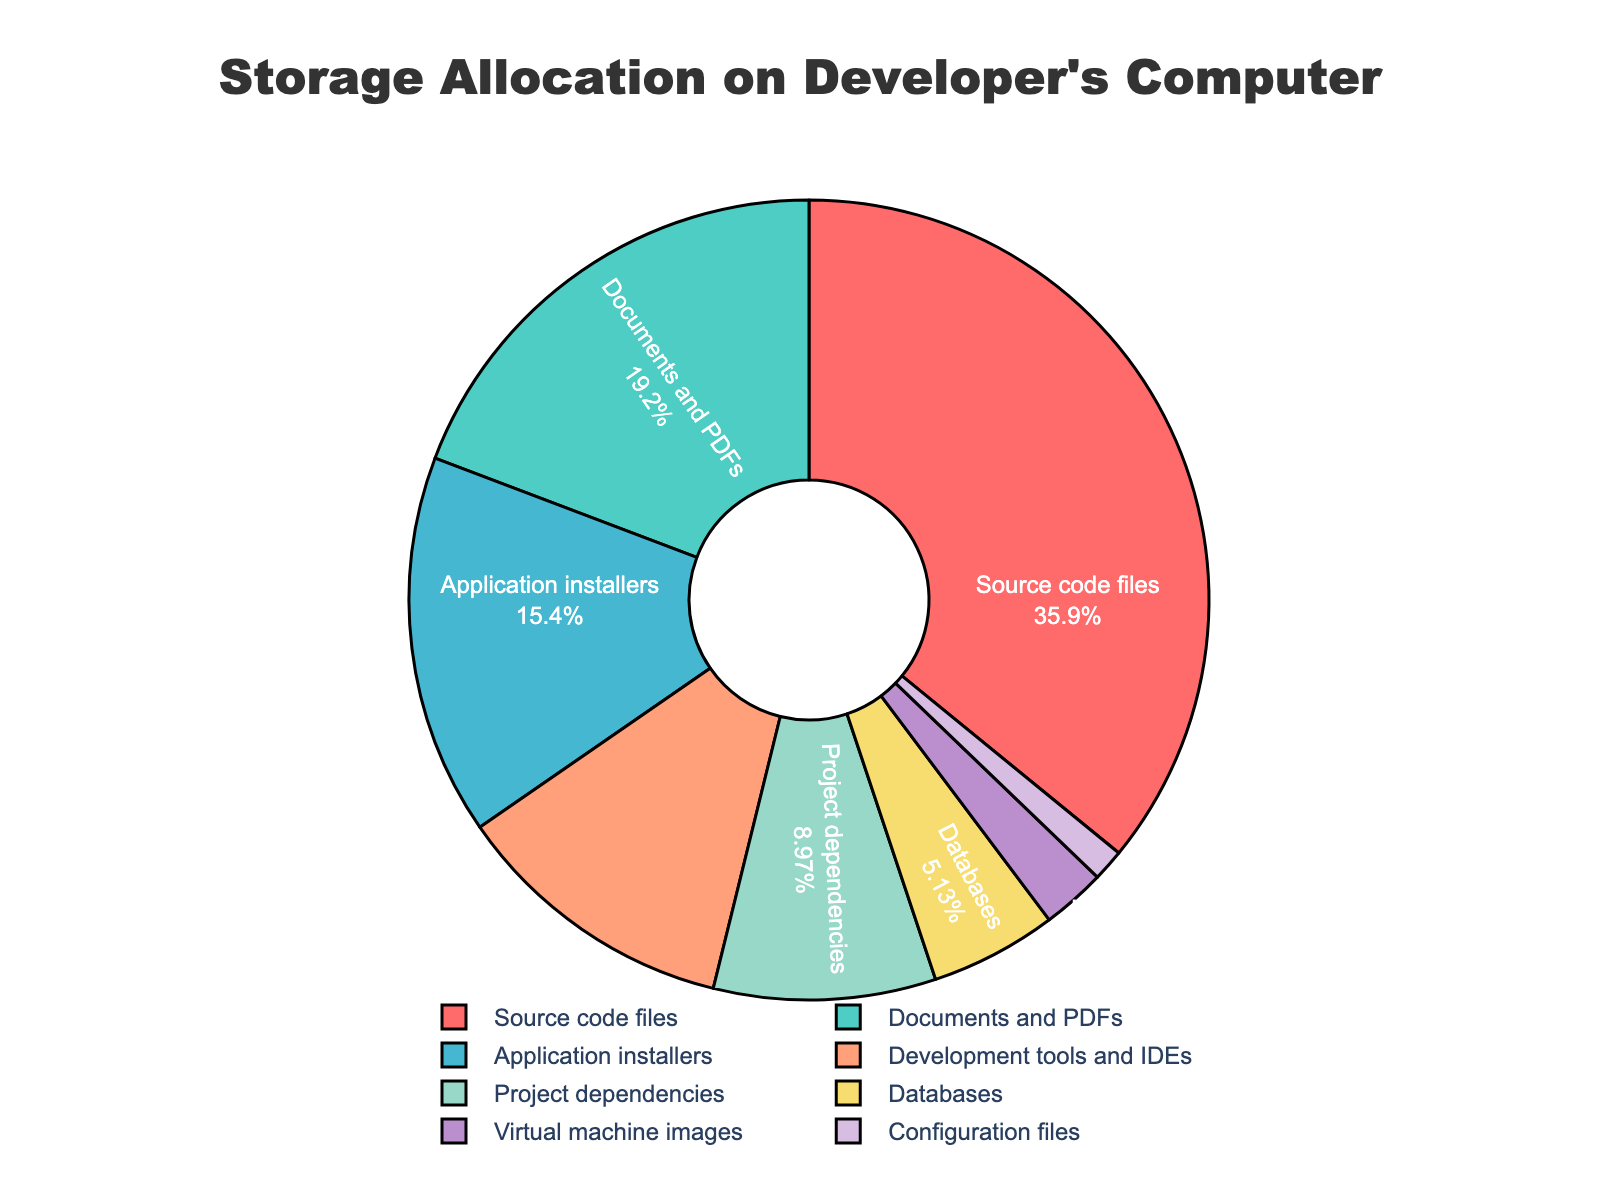What file type occupies the largest percentage of storage? The segment labeled "Source code files" is the largest on the pie chart, which indicates it occupies the highest percentage of storage space.
Answer: Source code files Which file type has a smaller allocation than Development tools and IDEs but larger than Configuration files? Documents and PDFs occupy 15%, which is greater than Development tools and IDEs at 9% and smaller than Configuration files at 1%.
Answer: Project dependencies How much more storage space do Application installers occupy compared to Databases? The pie chart shows Application installers occupy 12% of the storage space while Databases occupy 4%. The difference is calculated as 12% - 4% = 8%.
Answer: 8% Add the storage percentages of Virtual machine images, Development tools and IDEs, and Configuration files. Adding the percentages for Virtual machine images (2%), Development tools and IDEs (9%), and Configuration files (1%) results in 2% + 9% + 1% = 12%.
Answer: 12% Which file types together occupy exactly 30% of the storage space? Combining Databases (4%), Project dependencies (7%), Virtual machine images (2%), and Configuration files (1%) gives 4% + 7% + 2% + 1% = 14%, which is less. Adding Application installers (12%) to the sum results in 14% + 12% = 26%, still less. Finally, adding Development tools and IDEs (9%) to the sum results in 26% + 9% = 35%, which exceeds 30%. Initially, the largest values were considered so 15% + 12% + 3% yields 30%.
Answer: Documents and PDFs, Application installers, and Development tools and IDEs Compare the visual colors of Project dependencies and Development tools and IDEs sectors. The pie chart uses distinct colors for each segment. Project dependencies are marked with a shade of green, and Development tools and IDEs are marked with a shade of blue.
Answer: Green, Blue Which file type takes up the least space on a developer’s computer, and what color represents it? The smallest segment in the pie chart is labeled "Configuration files," which occupy 1% of the storage space and are shown in a distinct color, which is a shade of purple.
Answer: Configuration files, purple What is the total percentage of storage space allocated by Source code files and Documents and PDFs combined? The pie chart shows that Source code files occupy 28% and Documents and PDFs occupy 15%. Adding these together results in 28% + 15% = 43%.
Answer: 43% 